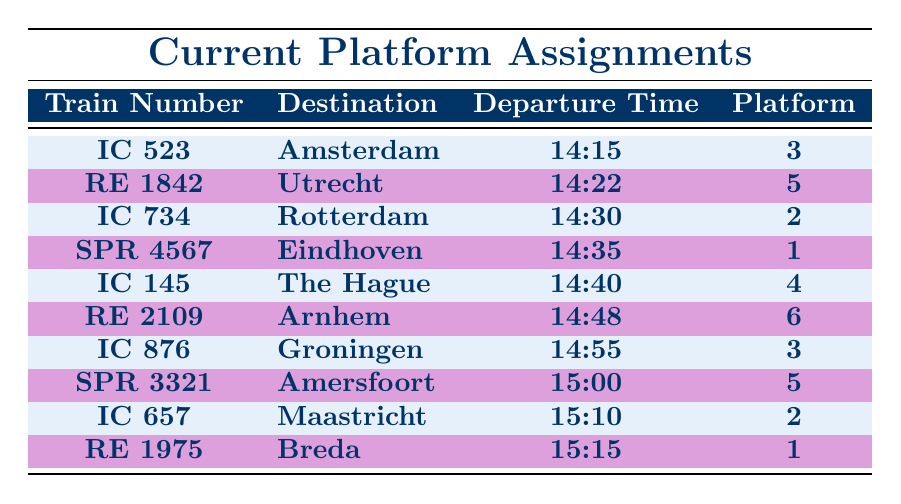What time does the train IC 657 depart? The table lists the departure time for each train, and for IC 657, it shows 15:10.
Answer: 15:10 Which platform is the train to Groningen departing from? The table indicates that the train IC 876, which goes to Groningen, will depart from platform 3.
Answer: Platform 3 Is there a train to The Hague departing before 14:40? Looking at the table, the last train before 14:40 is IC 734 to Rotterdam, which departs at 14:30. Therefore, the answer is yes, since it's the latest departure time before the specified time.
Answer: Yes What is the total number of trains departing from platform 5? From the table, we see two trains departing from platform 5: RE 1842 to Utrecht and SPR 3321 to Amersfoort. The total is therefore 2.
Answer: 2 Are there any trains departing to Arnhem after 14:48? The table shows that the train RE 2109 is the only one to Arnhem and it departs at 14:48. Since there are no other trains listed to Arnhem afterward, the answer is no.
Answer: No What is the next departure time after 14:35? After examining the table, the next departure after 14:35 is for IC 145 to The Hague, which leaves at 14:40.
Answer: 14:40 How many minutes are there between the departures of the trains to Amsterdam and Utrecht? The train to Amsterdam (IC 523) departs at 14:15 and the train to Utrecht (RE 1842) departs at 14:22. The difference of time is 14:22 - 14:15, which is 7 minutes.
Answer: 7 minutes Is the train to Breda departing from platform 1? According to the table, the train RE 1975 to Breda actually departs from platform 1, which confirms that the statement is true.
Answer: Yes What is the average departure time for the two trains departing from platform 2? The trains departing from platform 2 are IC 734 to Rotterdam at 14:30 and IC 657 to Maastricht at 15:10. By converting these times to minutes (14:30 = 870, 15:10 = 910) and averaging them, we get (870 + 910)/2 = 890 minutes. Converting back gives 14:50.
Answer: 14:50 